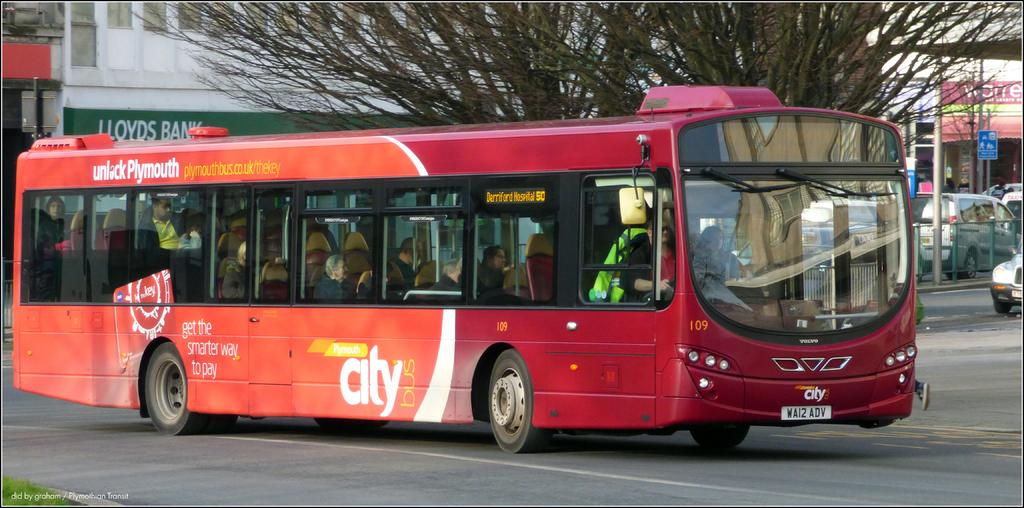<image>
Describe the image concisely. The number 50 Plymouth bus is heading to Derriford hospital. 